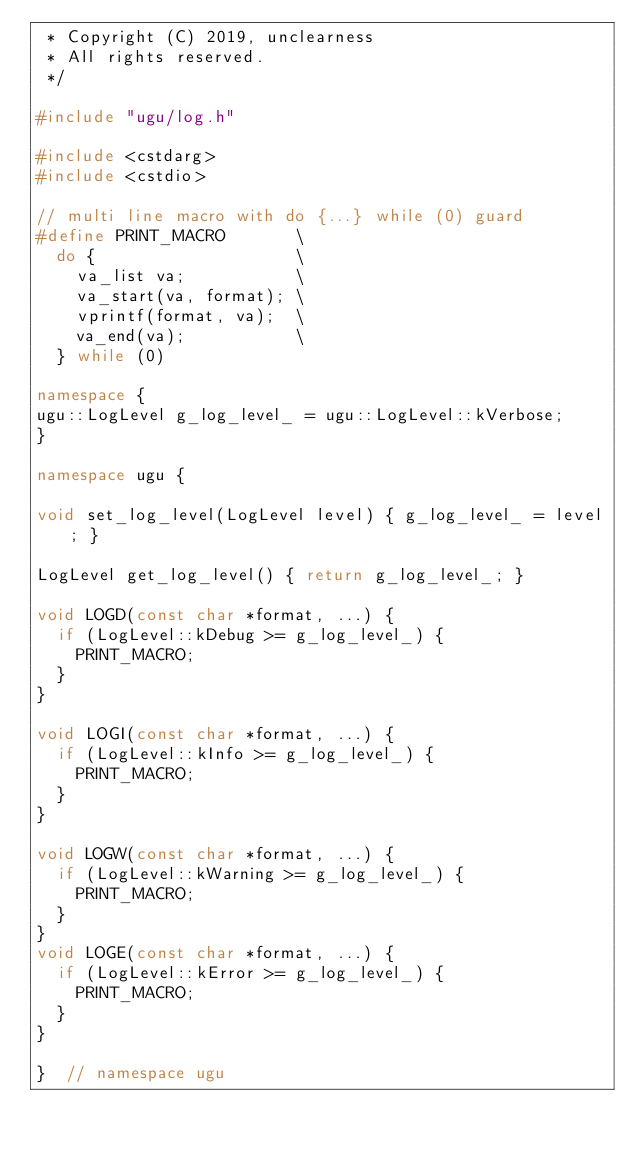<code> <loc_0><loc_0><loc_500><loc_500><_C++_> * Copyright (C) 2019, unclearness
 * All rights reserved.
 */

#include "ugu/log.h"

#include <cstdarg>
#include <cstdio>

// multi line macro with do {...} while (0) guard
#define PRINT_MACRO       \
  do {                    \
    va_list va;           \
    va_start(va, format); \
    vprintf(format, va);  \
    va_end(va);           \
  } while (0)

namespace {
ugu::LogLevel g_log_level_ = ugu::LogLevel::kVerbose;
}

namespace ugu {

void set_log_level(LogLevel level) { g_log_level_ = level; }

LogLevel get_log_level() { return g_log_level_; }

void LOGD(const char *format, ...) {
  if (LogLevel::kDebug >= g_log_level_) {
    PRINT_MACRO;
  }
}

void LOGI(const char *format, ...) {
  if (LogLevel::kInfo >= g_log_level_) {
    PRINT_MACRO;
  }
}

void LOGW(const char *format, ...) {
  if (LogLevel::kWarning >= g_log_level_) {
    PRINT_MACRO;
  }
}
void LOGE(const char *format, ...) {
  if (LogLevel::kError >= g_log_level_) {
    PRINT_MACRO;
  }
}

}  // namespace ugu
</code> 